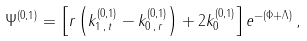Convert formula to latex. <formula><loc_0><loc_0><loc_500><loc_500>\Psi ^ { ( 0 , 1 ) } = \left [ r \left ( k _ { 1 \, , \, t } ^ { ( 0 , 1 ) } - k _ { 0 \, , \, r } ^ { ( 0 , 1 ) } \right ) + 2 k _ { 0 } ^ { ( 0 , 1 ) } \right ] e ^ { - \left ( \Phi + \Lambda \right ) } \, ,</formula> 